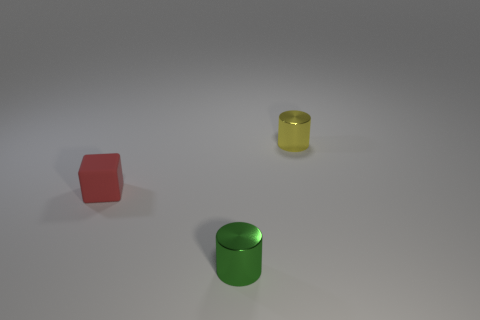There is a red thing that is on the left side of the cylinder that is behind the small shiny thing left of the small yellow thing; what shape is it?
Offer a very short reply. Cube. The green shiny cylinder has what size?
Offer a terse response. Small. Are there any small cyan things made of the same material as the tiny red cube?
Ensure brevity in your answer.  No. What size is the green shiny object that is the same shape as the tiny yellow shiny thing?
Provide a short and direct response. Small. Are there an equal number of tiny cylinders behind the small green shiny thing and large blue matte cubes?
Keep it short and to the point. No. There is a tiny metallic thing behind the small green cylinder; is it the same shape as the small red rubber object?
Provide a short and direct response. No. What is the shape of the small yellow shiny object?
Offer a terse response. Cylinder. What is the thing left of the tiny metallic cylinder that is in front of the small metallic cylinder that is behind the small red thing made of?
Your response must be concise. Rubber. What number of things are either green shiny objects or red objects?
Provide a succinct answer. 2. Is the material of the object that is on the left side of the green cylinder the same as the tiny green object?
Ensure brevity in your answer.  No. 